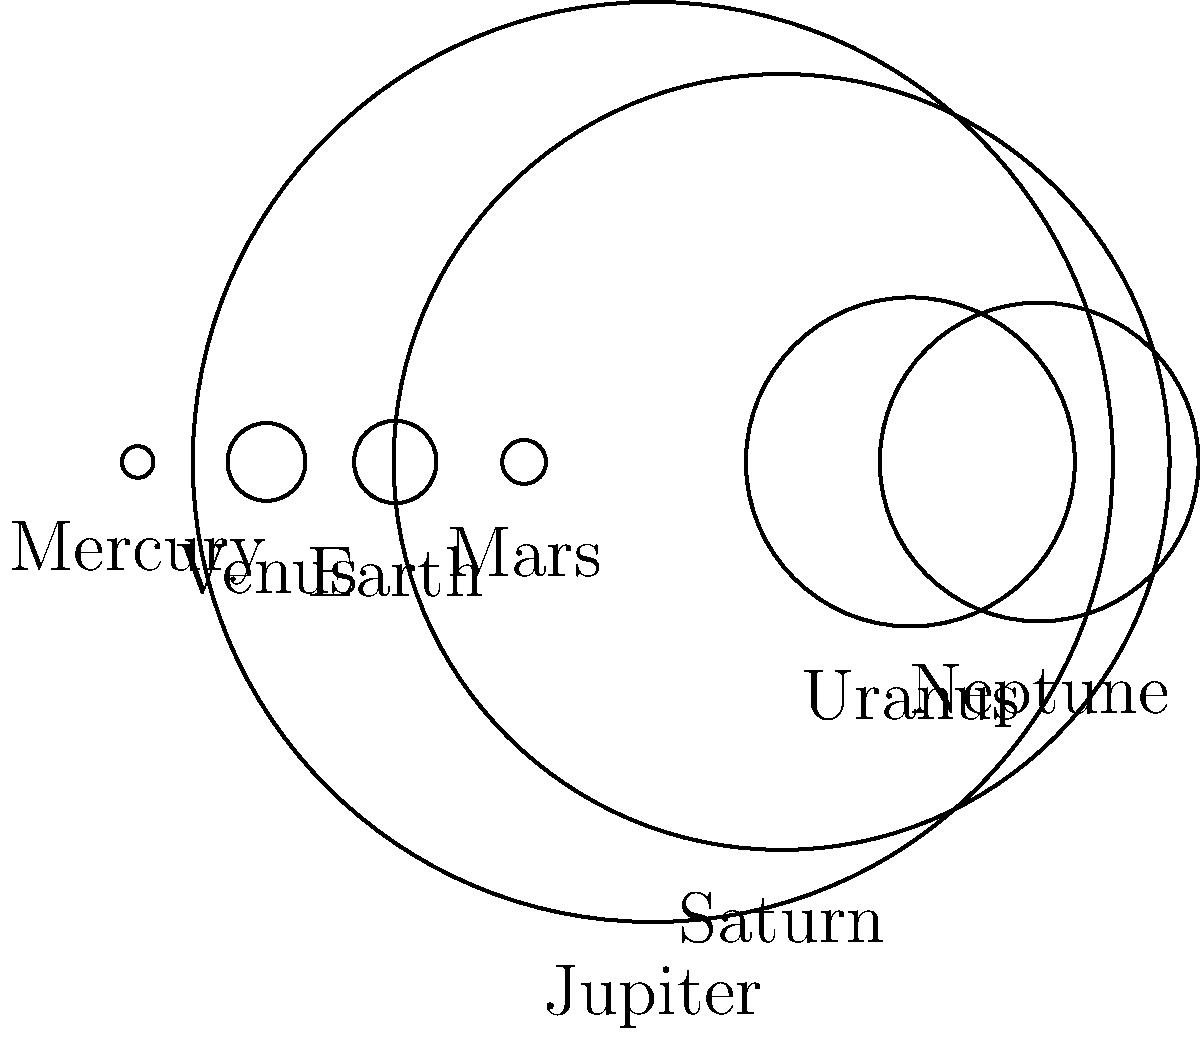In the image above, the planets of our solar system are represented by circles scaled according to their relative sizes. Which planet is represented by the second largest circle? To answer this question, we need to follow these steps:

1. Observe that the circles represent the planets in our solar system.
2. Recall that the sizes of the circles are proportional to the actual sizes of the planets.
3. Identify the largest circle, which represents Jupiter, the largest planet in our solar system.
4. Look for the second largest circle among the remaining planets.
5. The second largest circle represents Saturn, which is the second largest planet in our solar system.

Saturn is known for its beautiful ring system and is often called the "Jewel of the Solar System." It's a gas giant, like Jupiter, but slightly smaller. This representation helps us visualize the significant size difference between the gas giants (Jupiter and Saturn) and the smaller terrestrial planets like Earth and Mars.
Answer: Saturn 